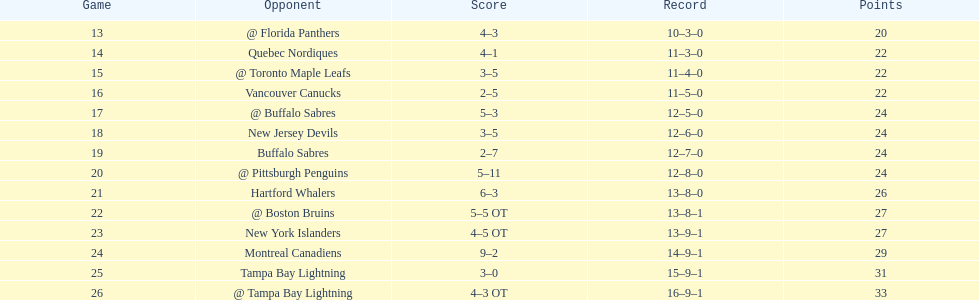Who recorded the highest number of assists for the flyers during the 1993-1994 season? Mark Recchi. 